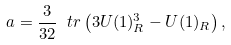<formula> <loc_0><loc_0><loc_500><loc_500>a = \frac { 3 } { 3 2 } \ t r \left ( 3 U ( 1 ) _ { R } ^ { 3 } - U ( 1 ) _ { R } \right ) ,</formula> 